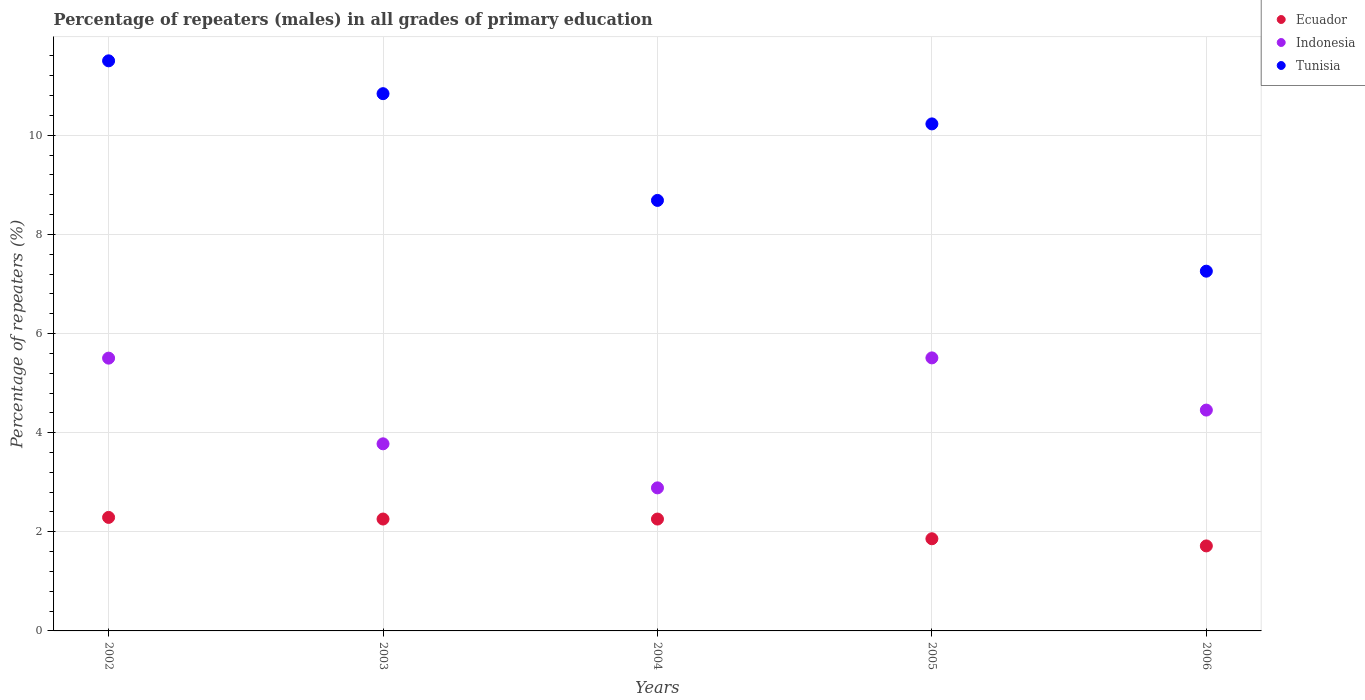How many different coloured dotlines are there?
Your response must be concise. 3. Is the number of dotlines equal to the number of legend labels?
Give a very brief answer. Yes. What is the percentage of repeaters (males) in Indonesia in 2005?
Make the answer very short. 5.51. Across all years, what is the maximum percentage of repeaters (males) in Indonesia?
Provide a succinct answer. 5.51. Across all years, what is the minimum percentage of repeaters (males) in Tunisia?
Make the answer very short. 7.26. In which year was the percentage of repeaters (males) in Tunisia maximum?
Your answer should be very brief. 2002. What is the total percentage of repeaters (males) in Tunisia in the graph?
Keep it short and to the point. 48.52. What is the difference between the percentage of repeaters (males) in Indonesia in 2003 and that in 2006?
Give a very brief answer. -0.68. What is the difference between the percentage of repeaters (males) in Ecuador in 2006 and the percentage of repeaters (males) in Indonesia in 2003?
Provide a short and direct response. -2.06. What is the average percentage of repeaters (males) in Indonesia per year?
Provide a short and direct response. 4.43. In the year 2004, what is the difference between the percentage of repeaters (males) in Tunisia and percentage of repeaters (males) in Indonesia?
Make the answer very short. 5.8. In how many years, is the percentage of repeaters (males) in Tunisia greater than 8 %?
Offer a very short reply. 4. What is the ratio of the percentage of repeaters (males) in Ecuador in 2003 to that in 2006?
Offer a very short reply. 1.32. Is the percentage of repeaters (males) in Tunisia in 2004 less than that in 2005?
Your answer should be very brief. Yes. What is the difference between the highest and the second highest percentage of repeaters (males) in Indonesia?
Provide a succinct answer. 0. What is the difference between the highest and the lowest percentage of repeaters (males) in Ecuador?
Provide a short and direct response. 0.58. In how many years, is the percentage of repeaters (males) in Ecuador greater than the average percentage of repeaters (males) in Ecuador taken over all years?
Your response must be concise. 3. Does the percentage of repeaters (males) in Indonesia monotonically increase over the years?
Your response must be concise. No. Is the percentage of repeaters (males) in Tunisia strictly less than the percentage of repeaters (males) in Ecuador over the years?
Offer a very short reply. No. How many dotlines are there?
Ensure brevity in your answer.  3. Are the values on the major ticks of Y-axis written in scientific E-notation?
Your answer should be compact. No. Does the graph contain any zero values?
Make the answer very short. No. Does the graph contain grids?
Make the answer very short. Yes. How many legend labels are there?
Keep it short and to the point. 3. How are the legend labels stacked?
Give a very brief answer. Vertical. What is the title of the graph?
Give a very brief answer. Percentage of repeaters (males) in all grades of primary education. What is the label or title of the X-axis?
Offer a very short reply. Years. What is the label or title of the Y-axis?
Keep it short and to the point. Percentage of repeaters (%). What is the Percentage of repeaters (%) of Ecuador in 2002?
Ensure brevity in your answer.  2.29. What is the Percentage of repeaters (%) in Indonesia in 2002?
Your answer should be very brief. 5.5. What is the Percentage of repeaters (%) in Tunisia in 2002?
Ensure brevity in your answer.  11.5. What is the Percentage of repeaters (%) of Ecuador in 2003?
Make the answer very short. 2.26. What is the Percentage of repeaters (%) of Indonesia in 2003?
Give a very brief answer. 3.78. What is the Percentage of repeaters (%) of Tunisia in 2003?
Make the answer very short. 10.84. What is the Percentage of repeaters (%) in Ecuador in 2004?
Your answer should be compact. 2.26. What is the Percentage of repeaters (%) of Indonesia in 2004?
Offer a very short reply. 2.89. What is the Percentage of repeaters (%) of Tunisia in 2004?
Keep it short and to the point. 8.69. What is the Percentage of repeaters (%) of Ecuador in 2005?
Your answer should be very brief. 1.86. What is the Percentage of repeaters (%) of Indonesia in 2005?
Give a very brief answer. 5.51. What is the Percentage of repeaters (%) of Tunisia in 2005?
Your answer should be compact. 10.23. What is the Percentage of repeaters (%) in Ecuador in 2006?
Your answer should be compact. 1.71. What is the Percentage of repeaters (%) of Indonesia in 2006?
Ensure brevity in your answer.  4.46. What is the Percentage of repeaters (%) of Tunisia in 2006?
Your answer should be very brief. 7.26. Across all years, what is the maximum Percentage of repeaters (%) of Ecuador?
Your answer should be compact. 2.29. Across all years, what is the maximum Percentage of repeaters (%) of Indonesia?
Offer a very short reply. 5.51. Across all years, what is the maximum Percentage of repeaters (%) of Tunisia?
Make the answer very short. 11.5. Across all years, what is the minimum Percentage of repeaters (%) of Ecuador?
Provide a short and direct response. 1.71. Across all years, what is the minimum Percentage of repeaters (%) of Indonesia?
Your answer should be very brief. 2.89. Across all years, what is the minimum Percentage of repeaters (%) in Tunisia?
Provide a short and direct response. 7.26. What is the total Percentage of repeaters (%) in Ecuador in the graph?
Provide a short and direct response. 10.38. What is the total Percentage of repeaters (%) of Indonesia in the graph?
Provide a succinct answer. 22.13. What is the total Percentage of repeaters (%) in Tunisia in the graph?
Your answer should be compact. 48.52. What is the difference between the Percentage of repeaters (%) in Ecuador in 2002 and that in 2003?
Provide a short and direct response. 0.03. What is the difference between the Percentage of repeaters (%) of Indonesia in 2002 and that in 2003?
Your answer should be compact. 1.73. What is the difference between the Percentage of repeaters (%) in Tunisia in 2002 and that in 2003?
Make the answer very short. 0.66. What is the difference between the Percentage of repeaters (%) of Ecuador in 2002 and that in 2004?
Your answer should be compact. 0.03. What is the difference between the Percentage of repeaters (%) of Indonesia in 2002 and that in 2004?
Your response must be concise. 2.62. What is the difference between the Percentage of repeaters (%) in Tunisia in 2002 and that in 2004?
Your answer should be compact. 2.82. What is the difference between the Percentage of repeaters (%) of Ecuador in 2002 and that in 2005?
Keep it short and to the point. 0.43. What is the difference between the Percentage of repeaters (%) of Indonesia in 2002 and that in 2005?
Provide a succinct answer. -0.01. What is the difference between the Percentage of repeaters (%) of Tunisia in 2002 and that in 2005?
Your answer should be compact. 1.27. What is the difference between the Percentage of repeaters (%) of Ecuador in 2002 and that in 2006?
Your answer should be very brief. 0.58. What is the difference between the Percentage of repeaters (%) of Indonesia in 2002 and that in 2006?
Provide a short and direct response. 1.05. What is the difference between the Percentage of repeaters (%) of Tunisia in 2002 and that in 2006?
Offer a terse response. 4.24. What is the difference between the Percentage of repeaters (%) in Ecuador in 2003 and that in 2004?
Provide a succinct answer. 0. What is the difference between the Percentage of repeaters (%) in Tunisia in 2003 and that in 2004?
Provide a short and direct response. 2.15. What is the difference between the Percentage of repeaters (%) in Ecuador in 2003 and that in 2005?
Offer a very short reply. 0.4. What is the difference between the Percentage of repeaters (%) of Indonesia in 2003 and that in 2005?
Provide a short and direct response. -1.73. What is the difference between the Percentage of repeaters (%) in Tunisia in 2003 and that in 2005?
Ensure brevity in your answer.  0.61. What is the difference between the Percentage of repeaters (%) of Ecuador in 2003 and that in 2006?
Keep it short and to the point. 0.54. What is the difference between the Percentage of repeaters (%) in Indonesia in 2003 and that in 2006?
Provide a short and direct response. -0.68. What is the difference between the Percentage of repeaters (%) of Tunisia in 2003 and that in 2006?
Give a very brief answer. 3.58. What is the difference between the Percentage of repeaters (%) of Ecuador in 2004 and that in 2005?
Make the answer very short. 0.4. What is the difference between the Percentage of repeaters (%) of Indonesia in 2004 and that in 2005?
Your answer should be compact. -2.62. What is the difference between the Percentage of repeaters (%) of Tunisia in 2004 and that in 2005?
Offer a very short reply. -1.54. What is the difference between the Percentage of repeaters (%) in Ecuador in 2004 and that in 2006?
Offer a very short reply. 0.54. What is the difference between the Percentage of repeaters (%) of Indonesia in 2004 and that in 2006?
Your answer should be very brief. -1.57. What is the difference between the Percentage of repeaters (%) of Tunisia in 2004 and that in 2006?
Offer a terse response. 1.43. What is the difference between the Percentage of repeaters (%) in Ecuador in 2005 and that in 2006?
Ensure brevity in your answer.  0.14. What is the difference between the Percentage of repeaters (%) of Indonesia in 2005 and that in 2006?
Offer a terse response. 1.05. What is the difference between the Percentage of repeaters (%) in Tunisia in 2005 and that in 2006?
Provide a short and direct response. 2.97. What is the difference between the Percentage of repeaters (%) of Ecuador in 2002 and the Percentage of repeaters (%) of Indonesia in 2003?
Give a very brief answer. -1.48. What is the difference between the Percentage of repeaters (%) in Ecuador in 2002 and the Percentage of repeaters (%) in Tunisia in 2003?
Your answer should be compact. -8.55. What is the difference between the Percentage of repeaters (%) of Indonesia in 2002 and the Percentage of repeaters (%) of Tunisia in 2003?
Offer a terse response. -5.34. What is the difference between the Percentage of repeaters (%) in Ecuador in 2002 and the Percentage of repeaters (%) in Indonesia in 2004?
Your answer should be very brief. -0.6. What is the difference between the Percentage of repeaters (%) in Ecuador in 2002 and the Percentage of repeaters (%) in Tunisia in 2004?
Ensure brevity in your answer.  -6.4. What is the difference between the Percentage of repeaters (%) in Indonesia in 2002 and the Percentage of repeaters (%) in Tunisia in 2004?
Your answer should be very brief. -3.18. What is the difference between the Percentage of repeaters (%) of Ecuador in 2002 and the Percentage of repeaters (%) of Indonesia in 2005?
Ensure brevity in your answer.  -3.22. What is the difference between the Percentage of repeaters (%) of Ecuador in 2002 and the Percentage of repeaters (%) of Tunisia in 2005?
Provide a succinct answer. -7.94. What is the difference between the Percentage of repeaters (%) in Indonesia in 2002 and the Percentage of repeaters (%) in Tunisia in 2005?
Ensure brevity in your answer.  -4.73. What is the difference between the Percentage of repeaters (%) of Ecuador in 2002 and the Percentage of repeaters (%) of Indonesia in 2006?
Provide a short and direct response. -2.17. What is the difference between the Percentage of repeaters (%) in Ecuador in 2002 and the Percentage of repeaters (%) in Tunisia in 2006?
Offer a very short reply. -4.97. What is the difference between the Percentage of repeaters (%) of Indonesia in 2002 and the Percentage of repeaters (%) of Tunisia in 2006?
Keep it short and to the point. -1.75. What is the difference between the Percentage of repeaters (%) of Ecuador in 2003 and the Percentage of repeaters (%) of Indonesia in 2004?
Your response must be concise. -0.63. What is the difference between the Percentage of repeaters (%) of Ecuador in 2003 and the Percentage of repeaters (%) of Tunisia in 2004?
Your response must be concise. -6.43. What is the difference between the Percentage of repeaters (%) in Indonesia in 2003 and the Percentage of repeaters (%) in Tunisia in 2004?
Give a very brief answer. -4.91. What is the difference between the Percentage of repeaters (%) in Ecuador in 2003 and the Percentage of repeaters (%) in Indonesia in 2005?
Offer a very short reply. -3.25. What is the difference between the Percentage of repeaters (%) of Ecuador in 2003 and the Percentage of repeaters (%) of Tunisia in 2005?
Make the answer very short. -7.97. What is the difference between the Percentage of repeaters (%) of Indonesia in 2003 and the Percentage of repeaters (%) of Tunisia in 2005?
Offer a terse response. -6.45. What is the difference between the Percentage of repeaters (%) in Ecuador in 2003 and the Percentage of repeaters (%) in Indonesia in 2006?
Your response must be concise. -2.2. What is the difference between the Percentage of repeaters (%) in Ecuador in 2003 and the Percentage of repeaters (%) in Tunisia in 2006?
Your answer should be very brief. -5. What is the difference between the Percentage of repeaters (%) of Indonesia in 2003 and the Percentage of repeaters (%) of Tunisia in 2006?
Provide a short and direct response. -3.48. What is the difference between the Percentage of repeaters (%) of Ecuador in 2004 and the Percentage of repeaters (%) of Indonesia in 2005?
Offer a terse response. -3.25. What is the difference between the Percentage of repeaters (%) in Ecuador in 2004 and the Percentage of repeaters (%) in Tunisia in 2005?
Offer a terse response. -7.97. What is the difference between the Percentage of repeaters (%) in Indonesia in 2004 and the Percentage of repeaters (%) in Tunisia in 2005?
Make the answer very short. -7.34. What is the difference between the Percentage of repeaters (%) in Ecuador in 2004 and the Percentage of repeaters (%) in Indonesia in 2006?
Your response must be concise. -2.2. What is the difference between the Percentage of repeaters (%) of Ecuador in 2004 and the Percentage of repeaters (%) of Tunisia in 2006?
Give a very brief answer. -5. What is the difference between the Percentage of repeaters (%) in Indonesia in 2004 and the Percentage of repeaters (%) in Tunisia in 2006?
Provide a short and direct response. -4.37. What is the difference between the Percentage of repeaters (%) in Ecuador in 2005 and the Percentage of repeaters (%) in Indonesia in 2006?
Your answer should be compact. -2.6. What is the difference between the Percentage of repeaters (%) in Ecuador in 2005 and the Percentage of repeaters (%) in Tunisia in 2006?
Offer a very short reply. -5.4. What is the difference between the Percentage of repeaters (%) of Indonesia in 2005 and the Percentage of repeaters (%) of Tunisia in 2006?
Your response must be concise. -1.75. What is the average Percentage of repeaters (%) in Ecuador per year?
Ensure brevity in your answer.  2.08. What is the average Percentage of repeaters (%) in Indonesia per year?
Your answer should be compact. 4.43. What is the average Percentage of repeaters (%) of Tunisia per year?
Provide a short and direct response. 9.7. In the year 2002, what is the difference between the Percentage of repeaters (%) in Ecuador and Percentage of repeaters (%) in Indonesia?
Your answer should be very brief. -3.21. In the year 2002, what is the difference between the Percentage of repeaters (%) in Ecuador and Percentage of repeaters (%) in Tunisia?
Make the answer very short. -9.21. In the year 2002, what is the difference between the Percentage of repeaters (%) of Indonesia and Percentage of repeaters (%) of Tunisia?
Your response must be concise. -6. In the year 2003, what is the difference between the Percentage of repeaters (%) of Ecuador and Percentage of repeaters (%) of Indonesia?
Your answer should be compact. -1.52. In the year 2003, what is the difference between the Percentage of repeaters (%) in Ecuador and Percentage of repeaters (%) in Tunisia?
Give a very brief answer. -8.58. In the year 2003, what is the difference between the Percentage of repeaters (%) in Indonesia and Percentage of repeaters (%) in Tunisia?
Offer a very short reply. -7.06. In the year 2004, what is the difference between the Percentage of repeaters (%) of Ecuador and Percentage of repeaters (%) of Indonesia?
Offer a terse response. -0.63. In the year 2004, what is the difference between the Percentage of repeaters (%) of Ecuador and Percentage of repeaters (%) of Tunisia?
Give a very brief answer. -6.43. In the year 2004, what is the difference between the Percentage of repeaters (%) in Indonesia and Percentage of repeaters (%) in Tunisia?
Provide a short and direct response. -5.8. In the year 2005, what is the difference between the Percentage of repeaters (%) in Ecuador and Percentage of repeaters (%) in Indonesia?
Your response must be concise. -3.65. In the year 2005, what is the difference between the Percentage of repeaters (%) of Ecuador and Percentage of repeaters (%) of Tunisia?
Keep it short and to the point. -8.37. In the year 2005, what is the difference between the Percentage of repeaters (%) in Indonesia and Percentage of repeaters (%) in Tunisia?
Your answer should be compact. -4.72. In the year 2006, what is the difference between the Percentage of repeaters (%) of Ecuador and Percentage of repeaters (%) of Indonesia?
Make the answer very short. -2.74. In the year 2006, what is the difference between the Percentage of repeaters (%) of Ecuador and Percentage of repeaters (%) of Tunisia?
Give a very brief answer. -5.54. In the year 2006, what is the difference between the Percentage of repeaters (%) of Indonesia and Percentage of repeaters (%) of Tunisia?
Provide a short and direct response. -2.8. What is the ratio of the Percentage of repeaters (%) of Ecuador in 2002 to that in 2003?
Your answer should be compact. 1.01. What is the ratio of the Percentage of repeaters (%) in Indonesia in 2002 to that in 2003?
Provide a succinct answer. 1.46. What is the ratio of the Percentage of repeaters (%) in Tunisia in 2002 to that in 2003?
Your response must be concise. 1.06. What is the ratio of the Percentage of repeaters (%) in Ecuador in 2002 to that in 2004?
Offer a very short reply. 1.01. What is the ratio of the Percentage of repeaters (%) in Indonesia in 2002 to that in 2004?
Your answer should be compact. 1.91. What is the ratio of the Percentage of repeaters (%) in Tunisia in 2002 to that in 2004?
Give a very brief answer. 1.32. What is the ratio of the Percentage of repeaters (%) in Ecuador in 2002 to that in 2005?
Offer a terse response. 1.23. What is the ratio of the Percentage of repeaters (%) in Tunisia in 2002 to that in 2005?
Your answer should be compact. 1.12. What is the ratio of the Percentage of repeaters (%) in Ecuador in 2002 to that in 2006?
Offer a terse response. 1.34. What is the ratio of the Percentage of repeaters (%) in Indonesia in 2002 to that in 2006?
Ensure brevity in your answer.  1.24. What is the ratio of the Percentage of repeaters (%) in Tunisia in 2002 to that in 2006?
Your answer should be compact. 1.58. What is the ratio of the Percentage of repeaters (%) of Indonesia in 2003 to that in 2004?
Your response must be concise. 1.31. What is the ratio of the Percentage of repeaters (%) in Tunisia in 2003 to that in 2004?
Provide a succinct answer. 1.25. What is the ratio of the Percentage of repeaters (%) in Ecuador in 2003 to that in 2005?
Keep it short and to the point. 1.21. What is the ratio of the Percentage of repeaters (%) of Indonesia in 2003 to that in 2005?
Provide a short and direct response. 0.69. What is the ratio of the Percentage of repeaters (%) in Tunisia in 2003 to that in 2005?
Your answer should be compact. 1.06. What is the ratio of the Percentage of repeaters (%) of Ecuador in 2003 to that in 2006?
Keep it short and to the point. 1.32. What is the ratio of the Percentage of repeaters (%) of Indonesia in 2003 to that in 2006?
Offer a very short reply. 0.85. What is the ratio of the Percentage of repeaters (%) of Tunisia in 2003 to that in 2006?
Make the answer very short. 1.49. What is the ratio of the Percentage of repeaters (%) of Ecuador in 2004 to that in 2005?
Make the answer very short. 1.21. What is the ratio of the Percentage of repeaters (%) of Indonesia in 2004 to that in 2005?
Ensure brevity in your answer.  0.52. What is the ratio of the Percentage of repeaters (%) of Tunisia in 2004 to that in 2005?
Offer a terse response. 0.85. What is the ratio of the Percentage of repeaters (%) in Ecuador in 2004 to that in 2006?
Provide a succinct answer. 1.32. What is the ratio of the Percentage of repeaters (%) in Indonesia in 2004 to that in 2006?
Provide a short and direct response. 0.65. What is the ratio of the Percentage of repeaters (%) of Tunisia in 2004 to that in 2006?
Your answer should be compact. 1.2. What is the ratio of the Percentage of repeaters (%) in Ecuador in 2005 to that in 2006?
Offer a very short reply. 1.08. What is the ratio of the Percentage of repeaters (%) of Indonesia in 2005 to that in 2006?
Offer a very short reply. 1.24. What is the ratio of the Percentage of repeaters (%) of Tunisia in 2005 to that in 2006?
Provide a short and direct response. 1.41. What is the difference between the highest and the second highest Percentage of repeaters (%) in Ecuador?
Your response must be concise. 0.03. What is the difference between the highest and the second highest Percentage of repeaters (%) in Indonesia?
Provide a short and direct response. 0.01. What is the difference between the highest and the second highest Percentage of repeaters (%) of Tunisia?
Make the answer very short. 0.66. What is the difference between the highest and the lowest Percentage of repeaters (%) of Ecuador?
Offer a terse response. 0.58. What is the difference between the highest and the lowest Percentage of repeaters (%) in Indonesia?
Give a very brief answer. 2.62. What is the difference between the highest and the lowest Percentage of repeaters (%) of Tunisia?
Provide a succinct answer. 4.24. 